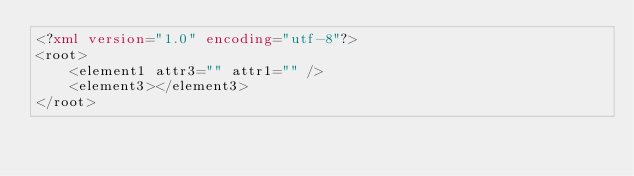<code> <loc_0><loc_0><loc_500><loc_500><_XML_><?xml version="1.0" encoding="utf-8"?>
<root>
    <element1 attr3="" attr1="" />
    <element3></element3>
</root></code> 